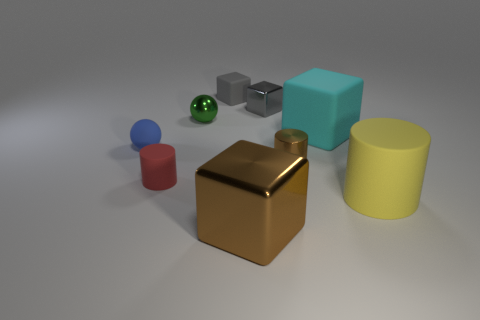Are there an equal number of small matte things that are left of the blue ball and metal cubes to the right of the yellow cylinder?
Provide a short and direct response. Yes. What is the color of the big object that is both left of the big yellow rubber thing and in front of the large cyan block?
Provide a succinct answer. Brown. What material is the brown object in front of the big thing on the right side of the cyan cube?
Offer a terse response. Metal. Is the size of the brown metallic cylinder the same as the blue rubber sphere?
Your answer should be very brief. Yes. What number of small objects are either green metallic spheres or shiny objects?
Ensure brevity in your answer.  3. There is a cyan matte cube; what number of big brown cubes are behind it?
Give a very brief answer. 0. Are there more tiny blue matte objects that are on the left side of the tiny metal cylinder than tiny shiny blocks?
Give a very brief answer. No. What shape is the tiny gray thing that is made of the same material as the cyan thing?
Offer a terse response. Cube. There is a cube left of the block in front of the yellow object; what is its color?
Your answer should be compact. Gray. Do the big yellow thing and the cyan matte object have the same shape?
Offer a terse response. No. 